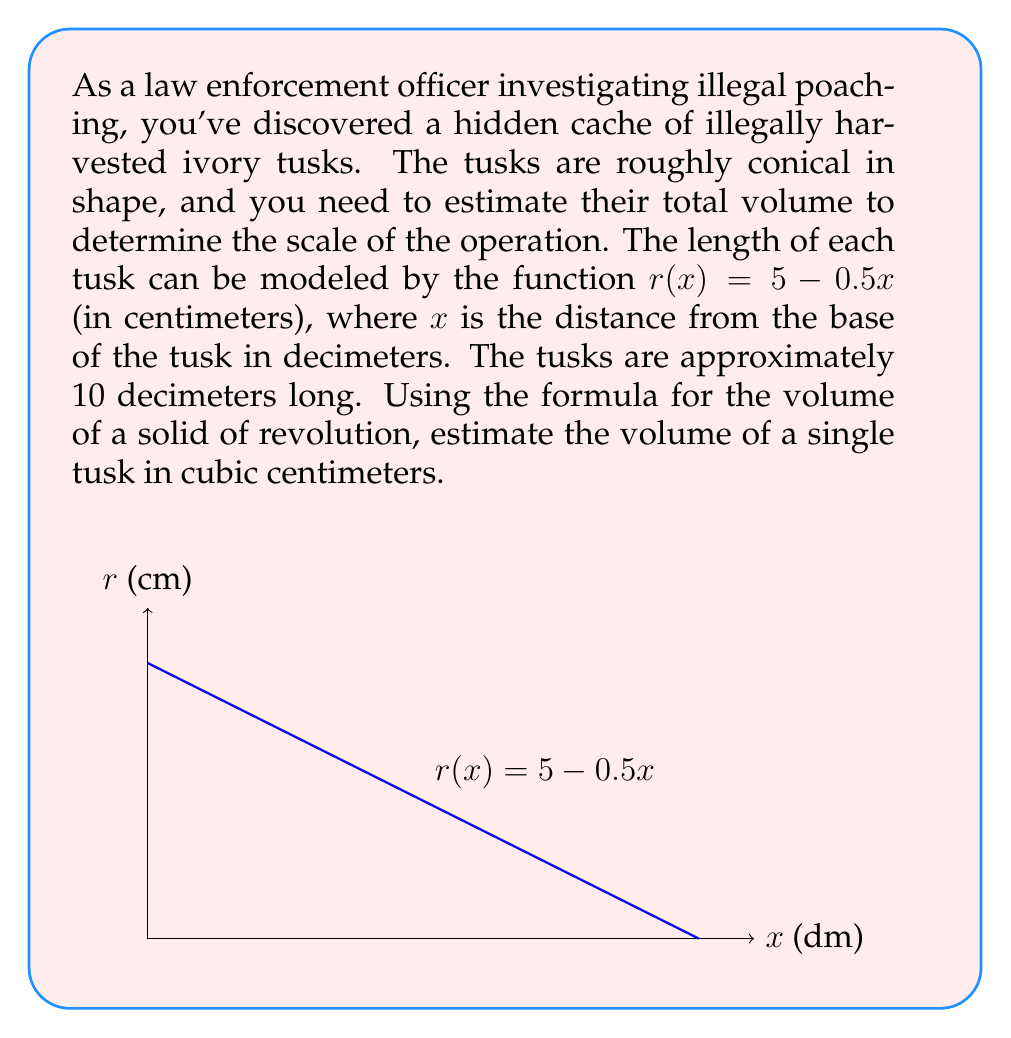What is the answer to this math problem? Let's approach this step-by-step:

1) The volume of a solid of revolution around the x-axis is given by the formula:

   $$V = \pi \int_{a}^{b} [r(x)]^2 dx$$

   where $r(x)$ is the radius function and $[a,b]$ is the interval.

2) In this case, $r(x) = 5 - 0.5x$, $a = 0$, and $b = 10$.

3) Let's substitute these into our formula:

   $$V = \pi \int_{0}^{10} (5 - 0.5x)^2 dx$$

4) Expand the squared term:

   $$V = \pi \int_{0}^{10} (25 - 5x + 0.25x^2) dx$$

5) Now we can integrate:

   $$V = \pi [25x - \frac{5}{2}x^2 + \frac{0.25}{3}x^3]_{0}^{10}$$

6) Evaluate at the limits:

   $$V = \pi [(250 - 125 + \frac{250}{12}) - (0 - 0 + 0)]$$

   $$V = \pi (125 + \frac{250}{12}) = \pi (\frac{1500 + 250}{12})$$

   $$V = \pi (\frac{1750}{12}) \approx 456.62$$

7) Therefore, the volume is approximately 456.62 cubic centimeters.
Answer: 456.62 cm³ 